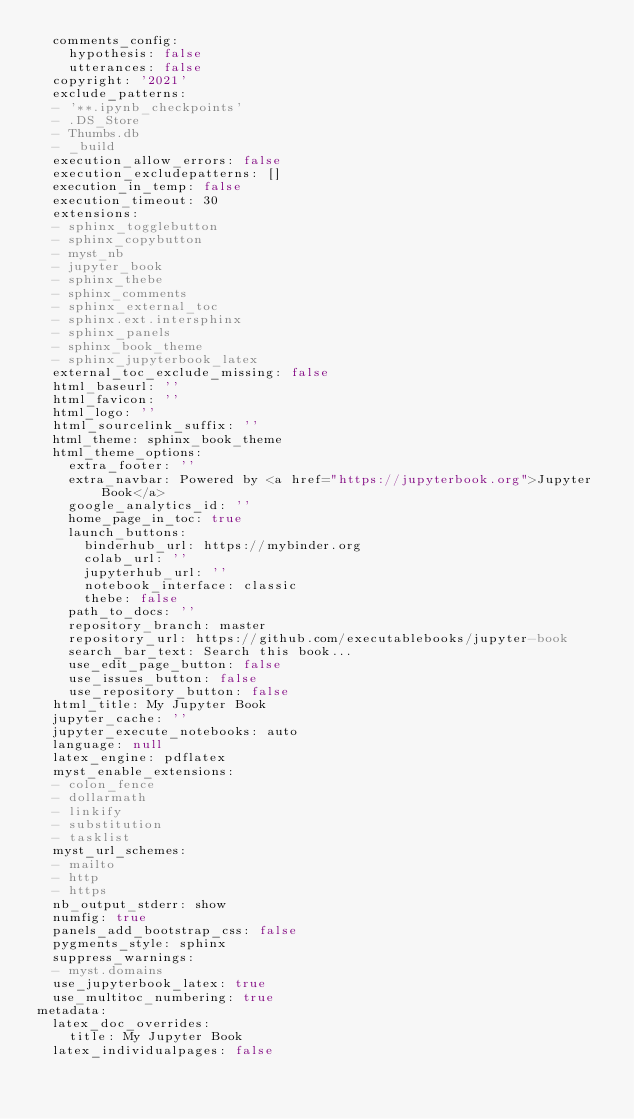<code> <loc_0><loc_0><loc_500><loc_500><_YAML_>  comments_config:
    hypothesis: false
    utterances: false
  copyright: '2021'
  exclude_patterns:
  - '**.ipynb_checkpoints'
  - .DS_Store
  - Thumbs.db
  - _build
  execution_allow_errors: false
  execution_excludepatterns: []
  execution_in_temp: false
  execution_timeout: 30
  extensions:
  - sphinx_togglebutton
  - sphinx_copybutton
  - myst_nb
  - jupyter_book
  - sphinx_thebe
  - sphinx_comments
  - sphinx_external_toc
  - sphinx.ext.intersphinx
  - sphinx_panels
  - sphinx_book_theme
  - sphinx_jupyterbook_latex
  external_toc_exclude_missing: false
  html_baseurl: ''
  html_favicon: ''
  html_logo: ''
  html_sourcelink_suffix: ''
  html_theme: sphinx_book_theme
  html_theme_options:
    extra_footer: ''
    extra_navbar: Powered by <a href="https://jupyterbook.org">Jupyter Book</a>
    google_analytics_id: ''
    home_page_in_toc: true
    launch_buttons:
      binderhub_url: https://mybinder.org
      colab_url: ''
      jupyterhub_url: ''
      notebook_interface: classic
      thebe: false
    path_to_docs: ''
    repository_branch: master
    repository_url: https://github.com/executablebooks/jupyter-book
    search_bar_text: Search this book...
    use_edit_page_button: false
    use_issues_button: false
    use_repository_button: false
  html_title: My Jupyter Book
  jupyter_cache: ''
  jupyter_execute_notebooks: auto
  language: null
  latex_engine: pdflatex
  myst_enable_extensions:
  - colon_fence
  - dollarmath
  - linkify
  - substitution
  - tasklist
  myst_url_schemes:
  - mailto
  - http
  - https
  nb_output_stderr: show
  numfig: true
  panels_add_bootstrap_css: false
  pygments_style: sphinx
  suppress_warnings:
  - myst.domains
  use_jupyterbook_latex: true
  use_multitoc_numbering: true
metadata:
  latex_doc_overrides:
    title: My Jupyter Book
  latex_individualpages: false
</code> 